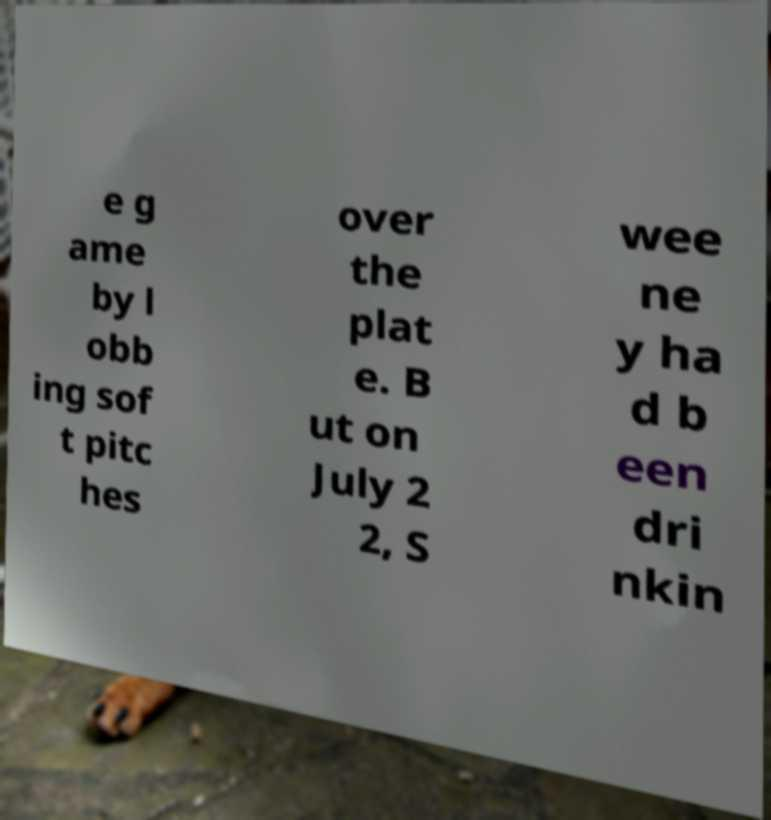Please read and relay the text visible in this image. What does it say? e g ame by l obb ing sof t pitc hes over the plat e. B ut on July 2 2, S wee ne y ha d b een dri nkin 